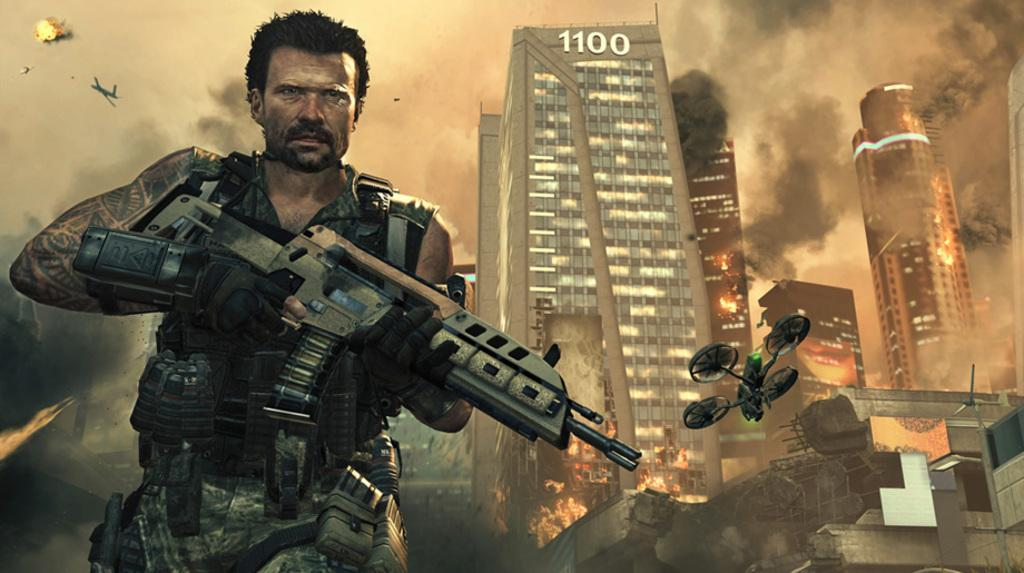What is the person in the image holding? The person is holding a gun in the image. What can be seen in the distance behind the person? There are buildings in the background of the image. What is the nature of the smoke in the image? Smoke is present in the image. What object is located on the right side of the image? There is a circular object on the right side of the image. What type of desk is visible in the image? There is no desk present in the image. Can you describe the basketball game happening in the background? There is no basketball game visible in the image; it features a person holding a gun, buildings in the background, smoke, and a circular object on the right side. 